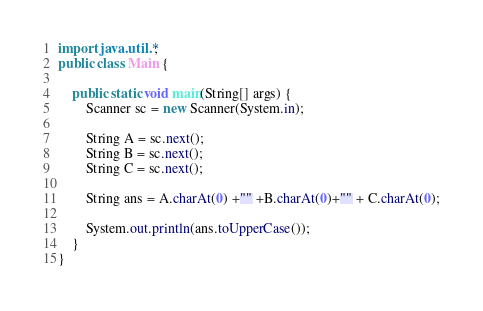<code> <loc_0><loc_0><loc_500><loc_500><_Java_>import java.util.*;
public class Main {
	
    public static void main(String[] args) {
        Scanner sc = new Scanner(System.in);
        
        String A = sc.next();
        String B = sc.next();
        String C = sc.next();
        
        String ans = A.charAt(0) +"" +B.charAt(0)+"" + C.charAt(0);
        
        System.out.println(ans.toUpperCase());
    }
}</code> 